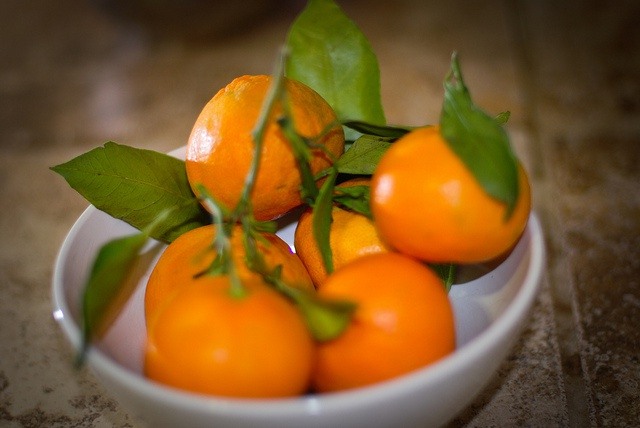Describe the objects in this image and their specific colors. I can see bowl in black, red, olive, darkgray, and brown tones, orange in black, orange, red, and olive tones, orange in black, orange, brown, and olive tones, orange in black, red, brown, olive, and orange tones, and orange in black, red, orange, and brown tones in this image. 